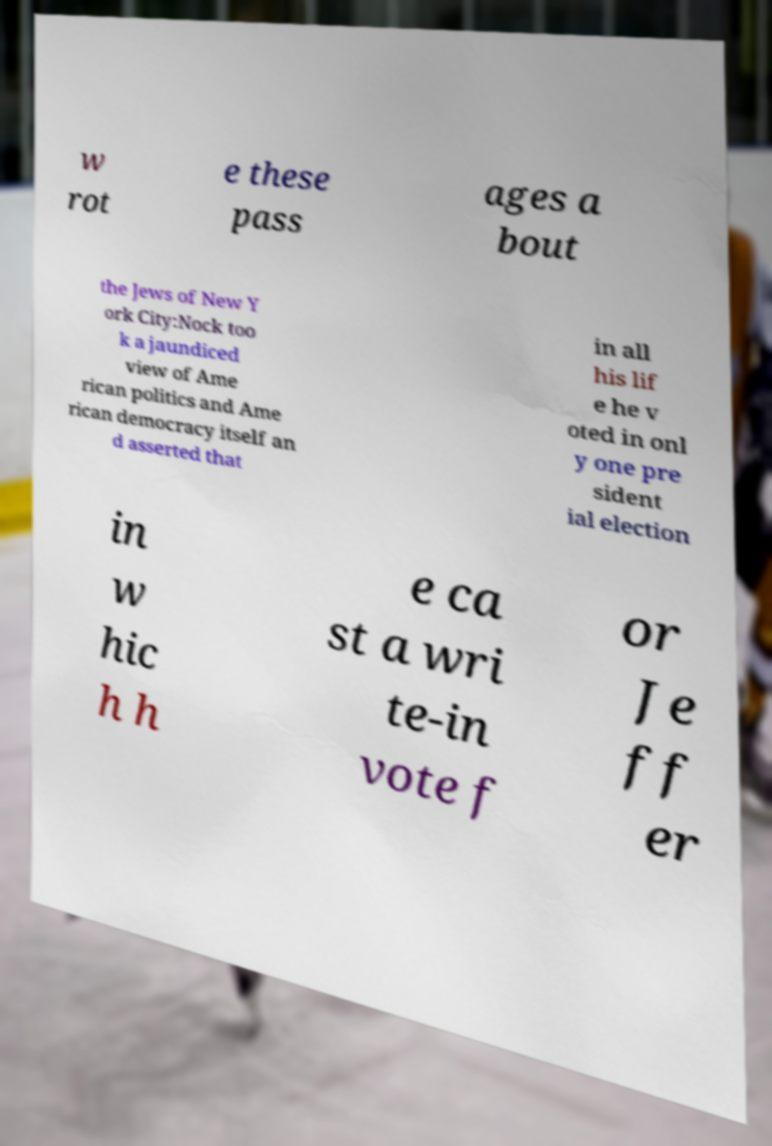Please identify and transcribe the text found in this image. w rot e these pass ages a bout the Jews of New Y ork City:Nock too k a jaundiced view of Ame rican politics and Ame rican democracy itself an d asserted that in all his lif e he v oted in onl y one pre sident ial election in w hic h h e ca st a wri te-in vote f or Je ff er 